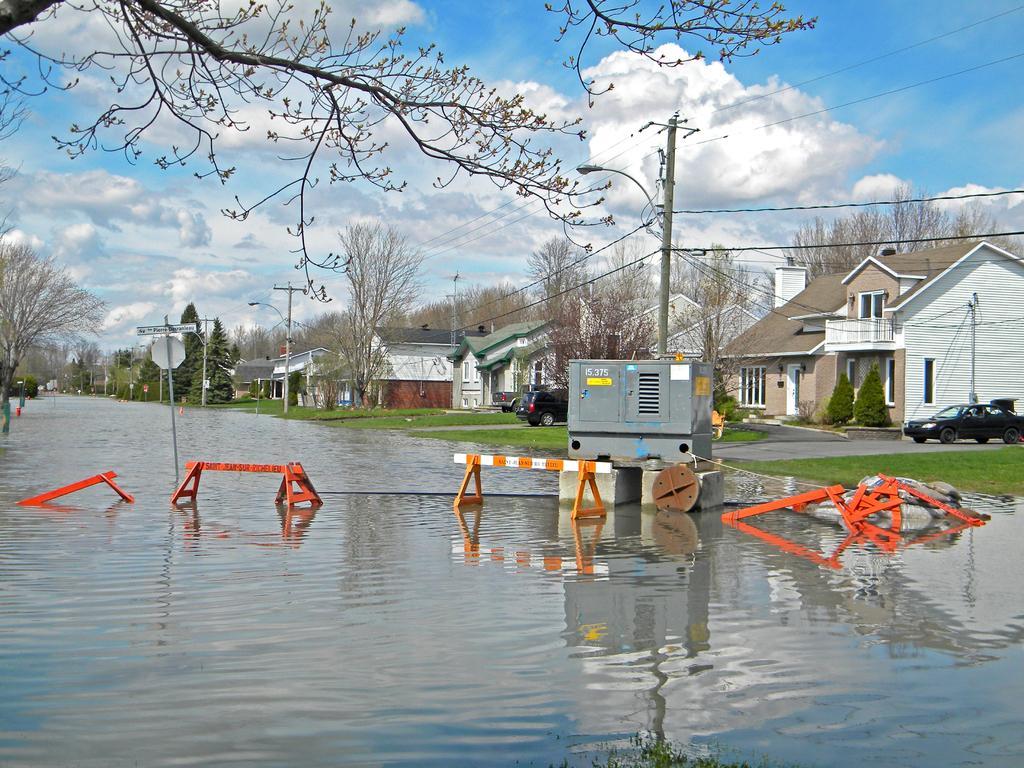In one or two sentences, can you explain what this image depicts? In the image we can see there are many buildings and these are the windows of the building, this is a grass, vehicle, road, electric pole, electric wires, trees, water and a cloudy sky. We can even see a light pole, there are objects in the water. 